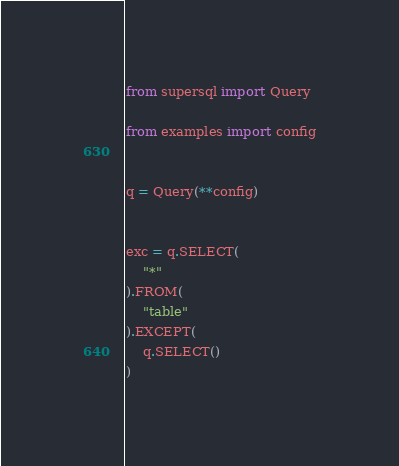Convert code to text. <code><loc_0><loc_0><loc_500><loc_500><_Python_>

from supersql import Query

from examples import config


q = Query(**config)


exc = q.SELECT(
    "*"
).FROM(
    "table"
).EXCEPT(
    q.SELECT()
)</code> 